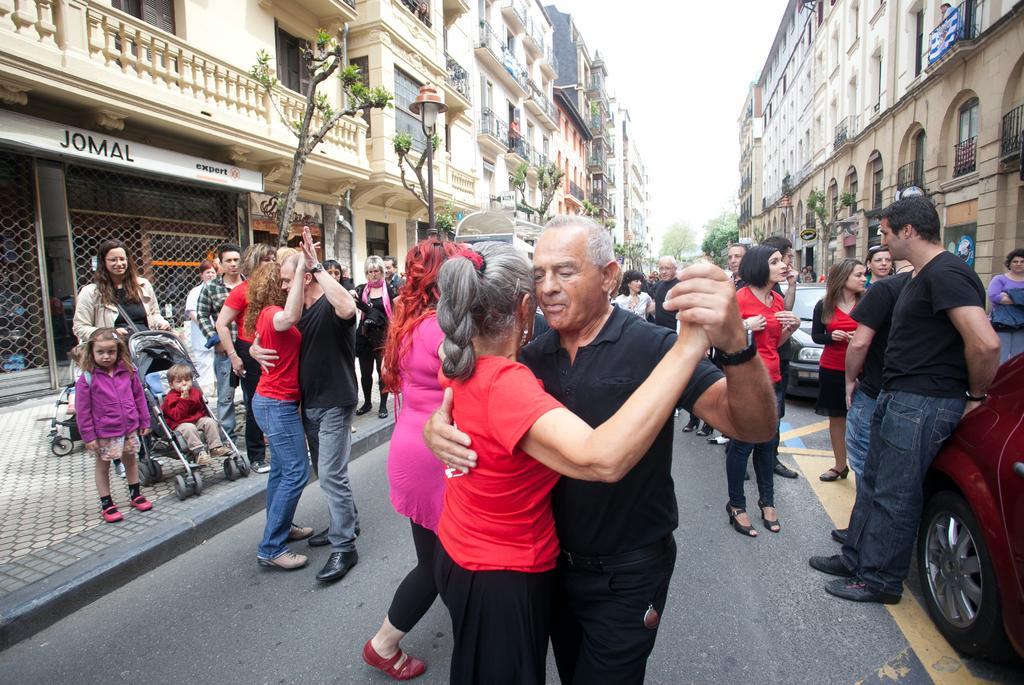In one or two sentences, can you explain what this image depicts? In this image, there are a few people and vehicles. We can see the ground. We can see some buildings and boards with text. We can see a baby trolley with a kid. There are a few trees. We can see some poles with lights. 